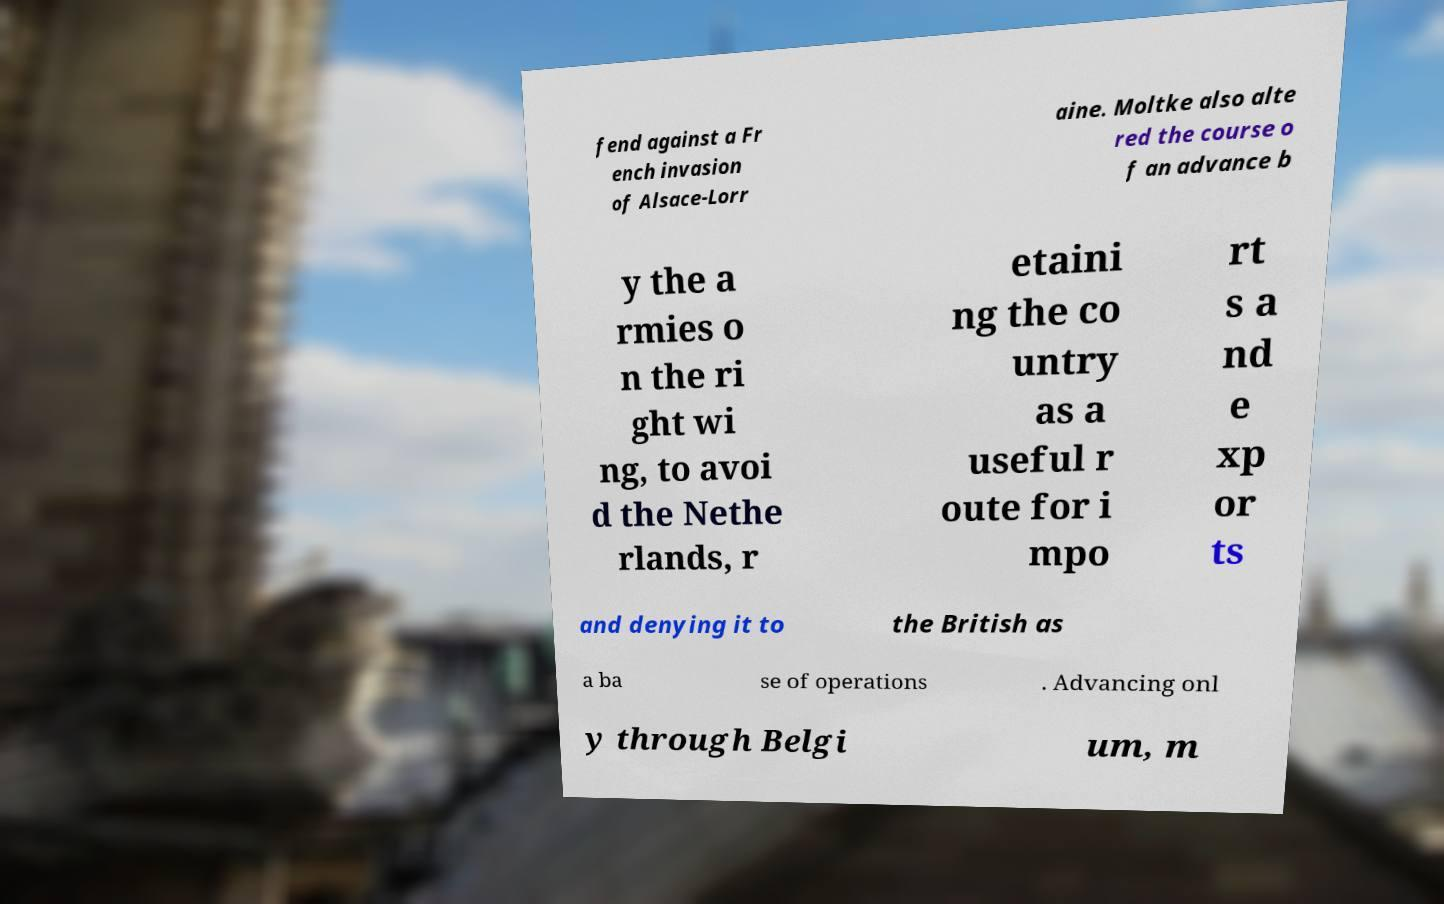Please identify and transcribe the text found in this image. fend against a Fr ench invasion of Alsace-Lorr aine. Moltke also alte red the course o f an advance b y the a rmies o n the ri ght wi ng, to avoi d the Nethe rlands, r etaini ng the co untry as a useful r oute for i mpo rt s a nd e xp or ts and denying it to the British as a ba se of operations . Advancing onl y through Belgi um, m 